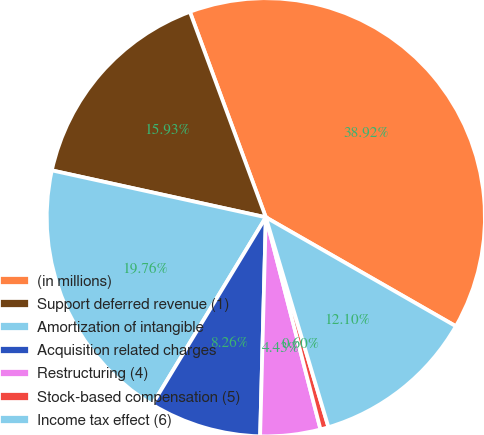<chart> <loc_0><loc_0><loc_500><loc_500><pie_chart><fcel>(in millions)<fcel>Support deferred revenue (1)<fcel>Amortization of intangible<fcel>Acquisition related charges<fcel>Restructuring (4)<fcel>Stock-based compensation (5)<fcel>Income tax effect (6)<nl><fcel>38.92%<fcel>15.93%<fcel>19.76%<fcel>8.26%<fcel>4.43%<fcel>0.6%<fcel>12.1%<nl></chart> 